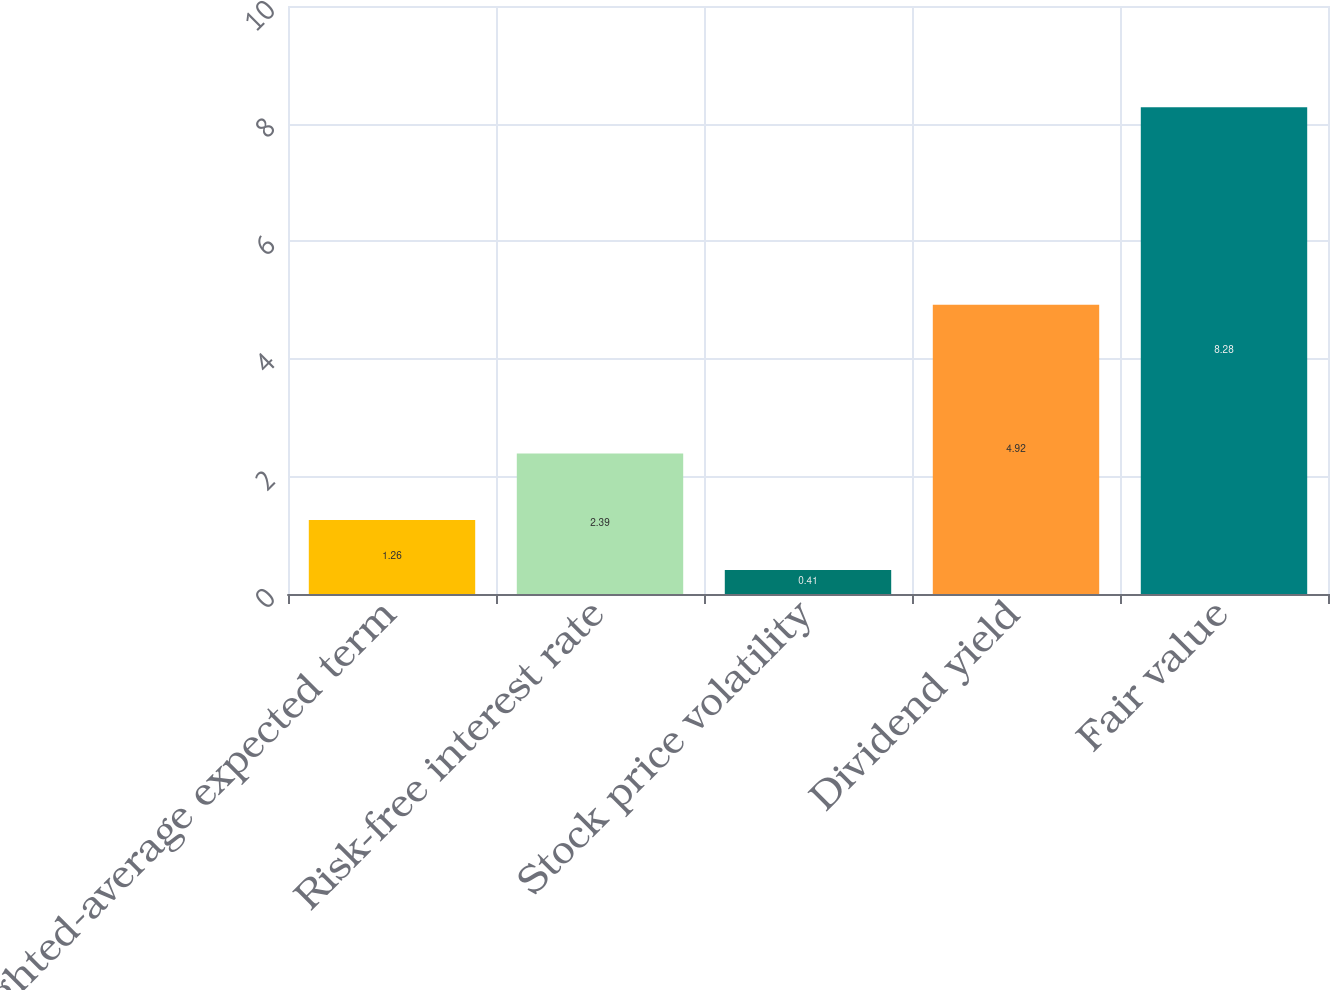Convert chart to OTSL. <chart><loc_0><loc_0><loc_500><loc_500><bar_chart><fcel>Weighted-average expected term<fcel>Risk-free interest rate<fcel>Stock price volatility<fcel>Dividend yield<fcel>Fair value<nl><fcel>1.26<fcel>2.39<fcel>0.41<fcel>4.92<fcel>8.28<nl></chart> 